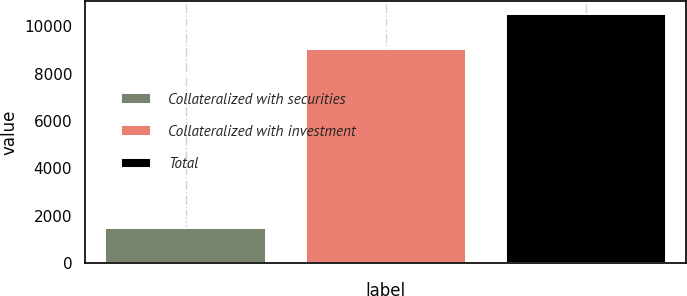Convert chart to OTSL. <chart><loc_0><loc_0><loc_500><loc_500><bar_chart><fcel>Collateralized with securities<fcel>Collateralized with investment<fcel>Total<nl><fcel>1475<fcel>9067<fcel>10542<nl></chart> 